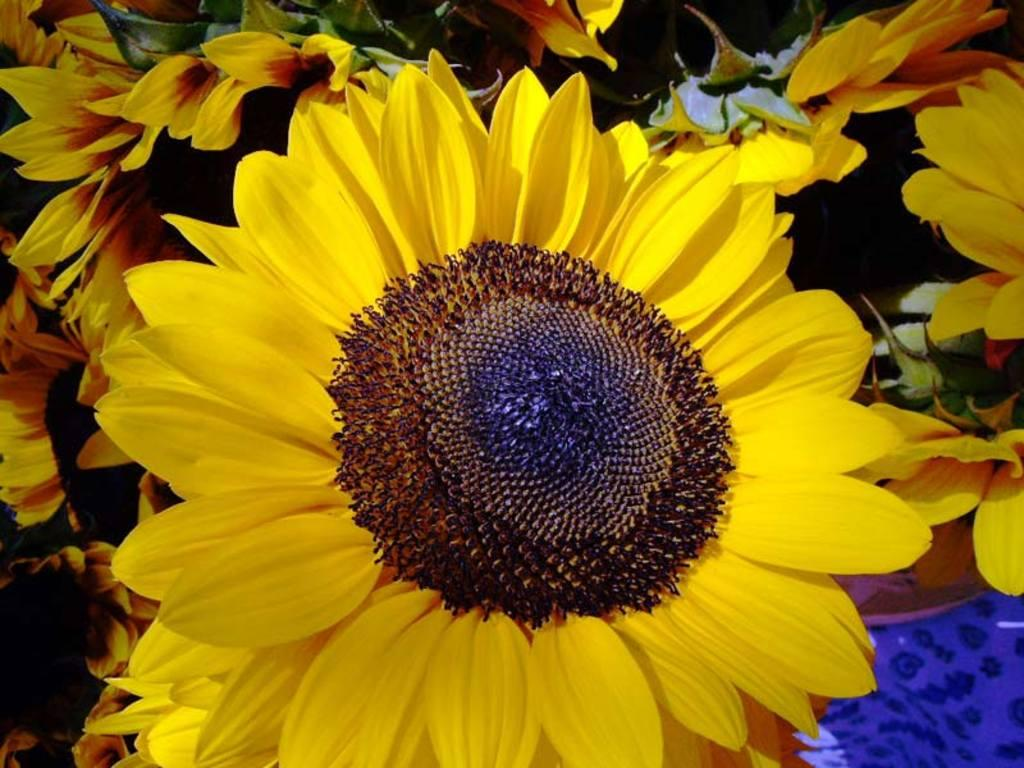What is the main subject of the image? The main subject of the image is a flower. Where is the flower located in the image? The flower is in the water. Can you see a rat playing with a ring near the flower in the image? No, there is no rat or ring present in the image; it only features a flower in the water. 